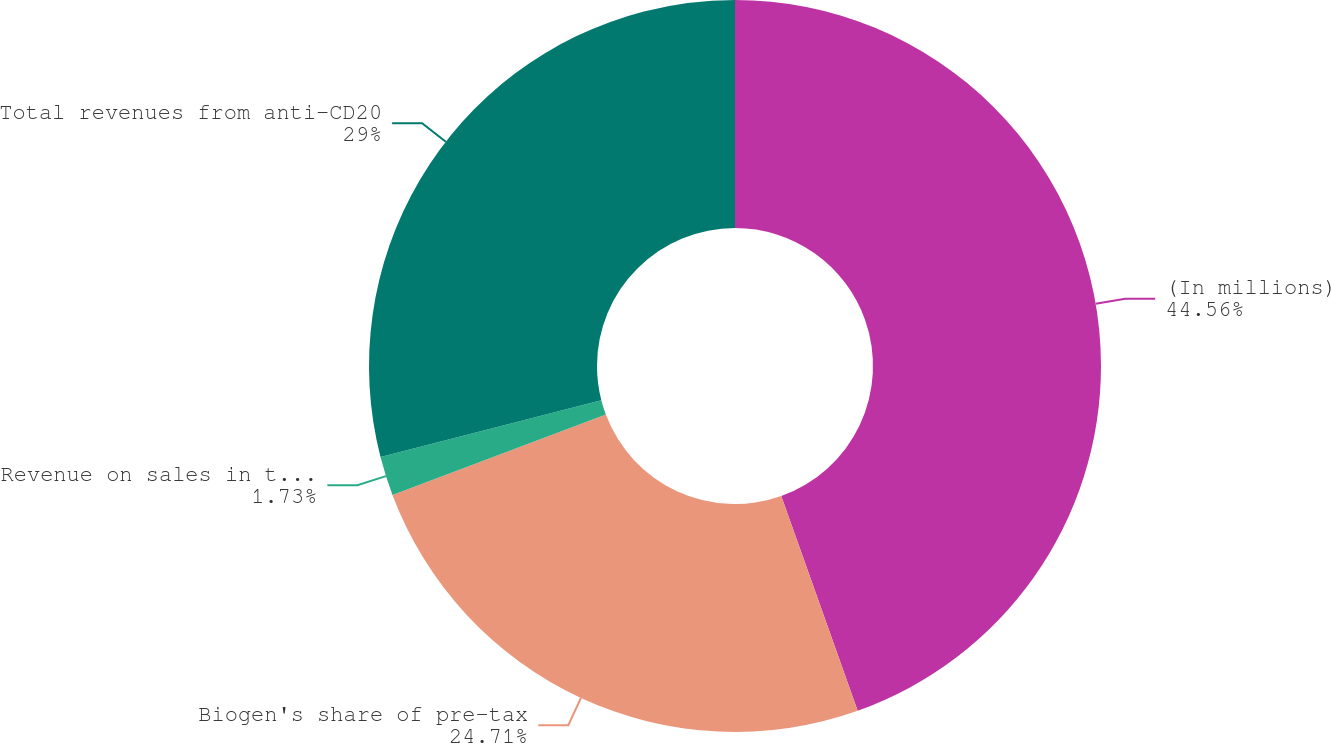Convert chart to OTSL. <chart><loc_0><loc_0><loc_500><loc_500><pie_chart><fcel>(In millions)<fcel>Biogen's share of pre-tax<fcel>Revenue on sales in the rest<fcel>Total revenues from anti-CD20<nl><fcel>44.56%<fcel>24.71%<fcel>1.73%<fcel>29.0%<nl></chart> 